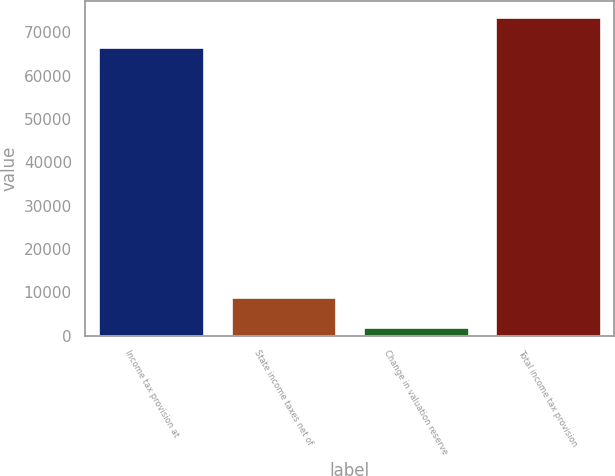Convert chart. <chart><loc_0><loc_0><loc_500><loc_500><bar_chart><fcel>Income tax provision at<fcel>State income taxes net of<fcel>Change in valuation reserve<fcel>Total income tax provision<nl><fcel>66652<fcel>8886.1<fcel>2039<fcel>73499.1<nl></chart> 